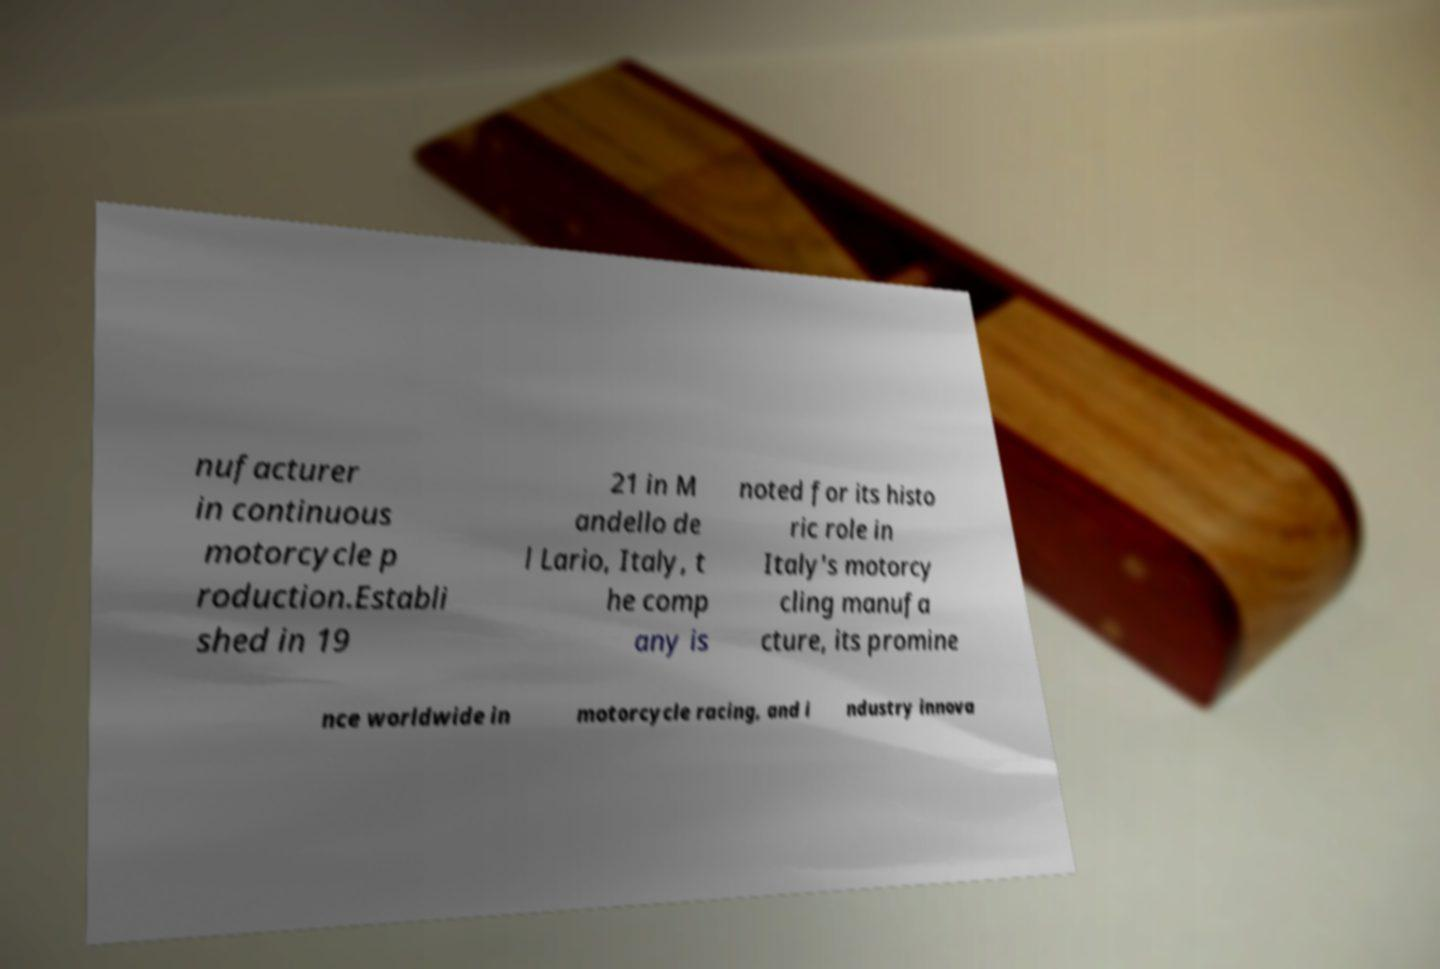What messages or text are displayed in this image? I need them in a readable, typed format. nufacturer in continuous motorcycle p roduction.Establi shed in 19 21 in M andello de l Lario, Italy, t he comp any is noted for its histo ric role in Italy's motorcy cling manufa cture, its promine nce worldwide in motorcycle racing, and i ndustry innova 